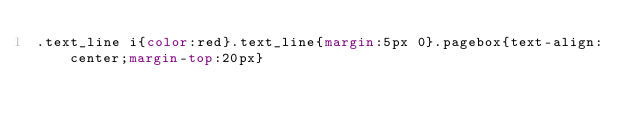<code> <loc_0><loc_0><loc_500><loc_500><_CSS_>.text_line i{color:red}.text_line{margin:5px 0}.pagebox{text-align:center;margin-top:20px}</code> 